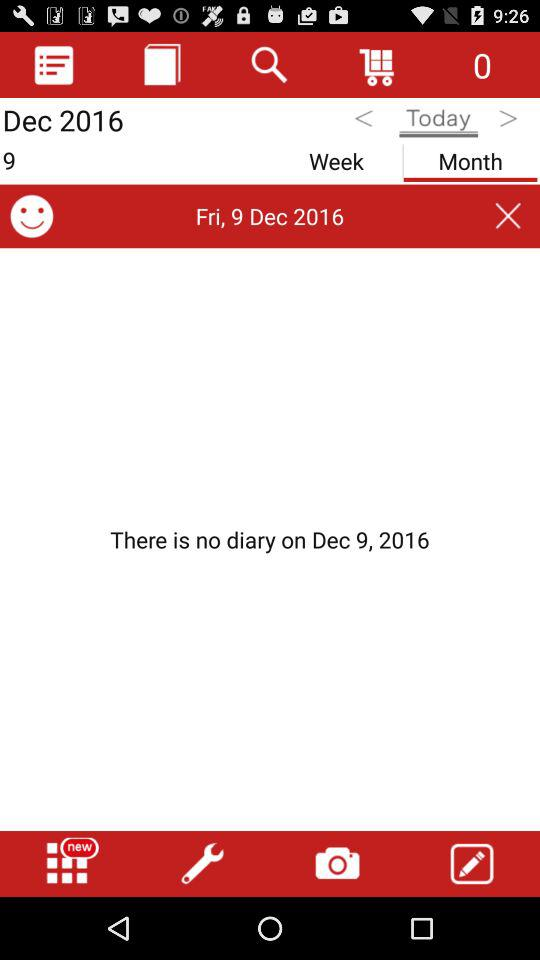Which tab has been selected? The tab that has been selected is "Month". 